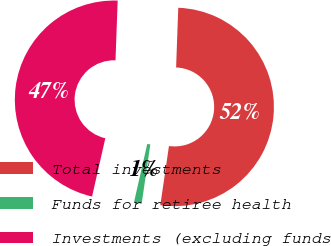Convert chart to OTSL. <chart><loc_0><loc_0><loc_500><loc_500><pie_chart><fcel>Total investments<fcel>Funds for retiree health<fcel>Investments (excluding funds<nl><fcel>51.73%<fcel>1.25%<fcel>47.02%<nl></chart> 